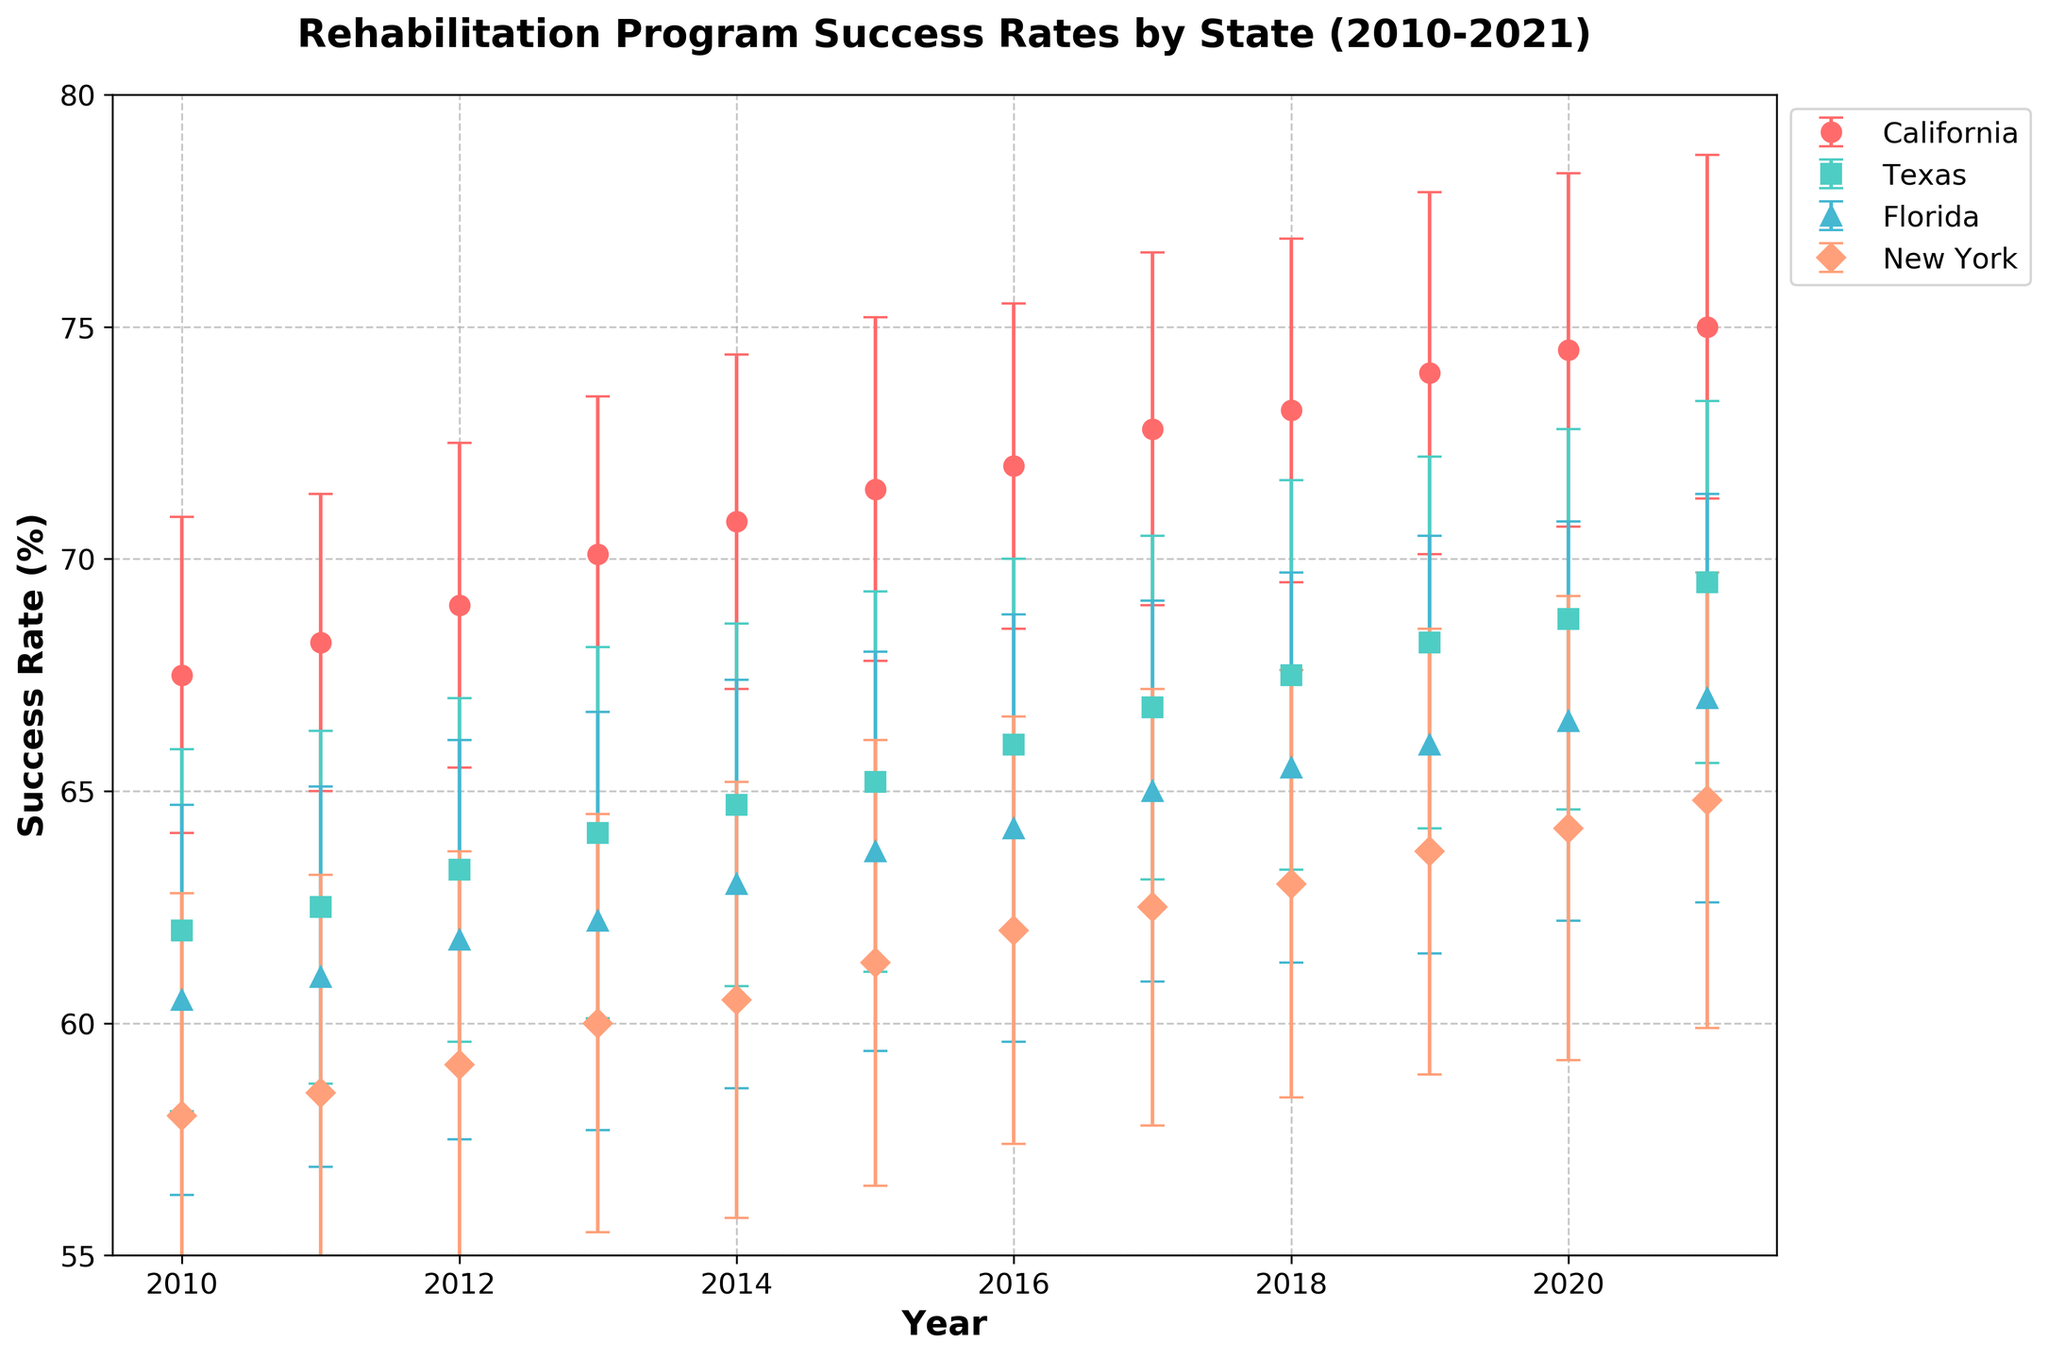What is the title of the figure? The title of the figure is located at the top of the plot and provides a summary of what the plot represents.
Answer: Rehabilitation Program Success Rates by State (2010-2021) What is the success rate of California in 2015? Locate the year 2015 on the x-axis, find the corresponding point on the California line (marked with circle), and read the success rate from the y-axis.
Answer: 71.5% Which state has the highest success rate in 2021? Find each state's data point for the year 2021 and identify the highest y-value. California has the highest success rate in 2021.
Answer: California Are the success rates for Texas in 2015 higher or lower compared to 2010? Compare the height of the points for Texas in the years 2015 and 2010 on the y-axis. The success rate increases from 62.0% in 2010 to 65.2% in 2015.
Answer: Higher Which state shows the most significant improvement in success rates from 2010 to 2021? Compare the difference in success rates between 2010 and 2021 for all states and identify which state has the largest increase. California shows the most improvement with an increase from 67.5% to 75.0%.
Answer: California What is the trend in Florida's success rate from 2010 to 2021? Follow the line for Florida from 2010 to 2021 and observe the overall direction. The trend is upward, indicating improvement over time.
Answer: Increasing Compare the variability of the success rates across states using error bars. Which state shows the highest variability? Look at the length of the error bars for each state. New York consistently has larger error bars, indicating higher variability.
Answer: New York How does the success rate in New York in 2013 compare to Texas in 2021? Identify the points for New York in 2013 and Texas in 2021 and compare their positions on the y-axis. New York's rate in 2013 is 60.0%, while Texas's rate in 2021 is 69.5%.
Answer: Lower Which state had a success rate closest to 70% in 2013? Locate the year 2013 on the x-axis, find the point closest to 70% on the y-axis, which is California with a success rate of 70.1%.
Answer: California What is the average success rate for California from 2010 to 2021? Sum the success rates for each year for California and divide by the number of years (12). The sum is 67.5 + 68.2 + 69.0 + 70.1 + 70.8 + 71.5 + 72.0 + 72.8 + 73.2 + 74.0 + 74.5 + 75.0 = 849.6. The average is 849.6 / 12.
Answer: 70.8% 